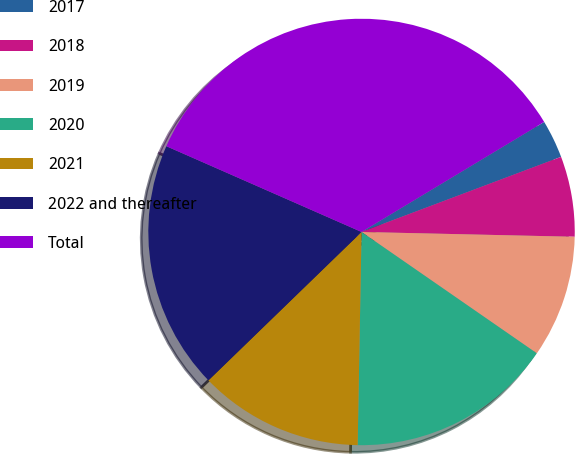Convert chart. <chart><loc_0><loc_0><loc_500><loc_500><pie_chart><fcel>2017<fcel>2018<fcel>2019<fcel>2020<fcel>2021<fcel>2022 and thereafter<fcel>Total<nl><fcel>2.9%<fcel>6.09%<fcel>9.28%<fcel>15.65%<fcel>12.46%<fcel>18.84%<fcel>34.78%<nl></chart> 